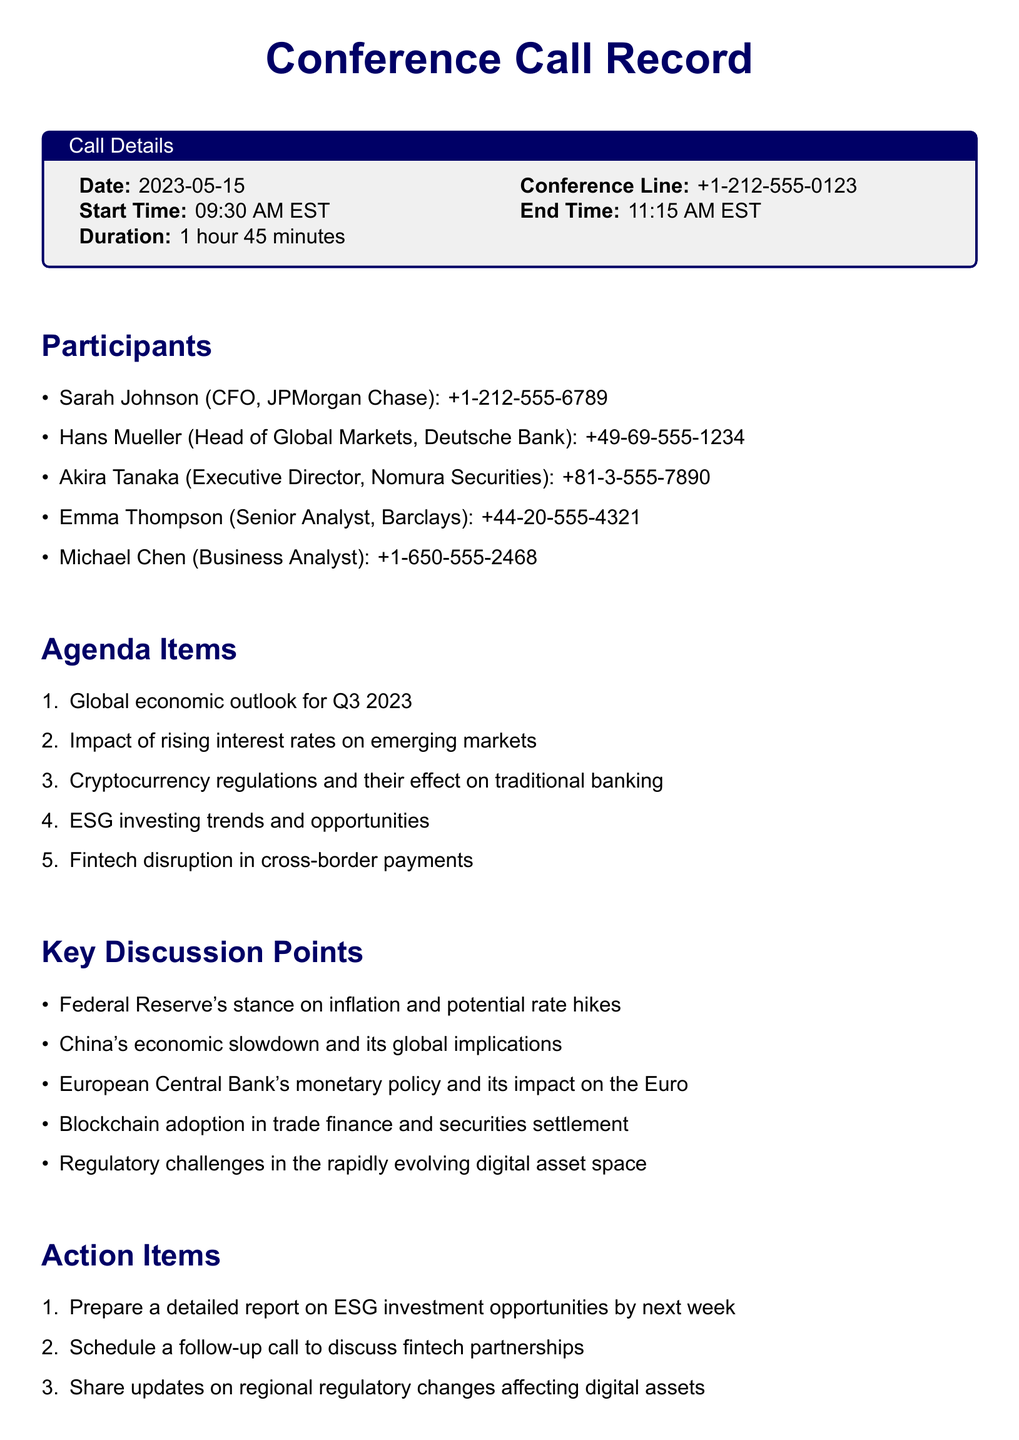What was the date of the conference call? The date is stated in the call details section of the document.
Answer: 2023-05-15 Who represented Deutsche Bank in the call? The participants list includes the representative from Deutsche Bank.
Answer: Hans Mueller What was the total duration of the call? The duration is specified clearly in the call details.
Answer: 1 hour 45 minutes What is one of the agenda items discussed? The agenda items are listed under the agenda section.
Answer: Global economic outlook for Q3 2023 Which participant is the CFO of JPMorgan Chase? The participants list includes the title and name of the representative from JPMorgan Chase.
Answer: Sarah Johnson What action item was determined regarding ESG investment? The action items section addresses specific tasks mentioned during the call.
Answer: Prepare a detailed report on ESG investment opportunities by next week What was one of the key discussion points? Key discussion points are highlighted in the document, indicating important topics covered.
Answer: Federal Reserve's stance on inflation and potential rate hikes How long was the call held? The document indicates the starting and ending time of the call, which helps determine the length.
Answer: 1 hour 45 minutes 